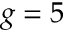Convert formula to latex. <formula><loc_0><loc_0><loc_500><loc_500>g = 5</formula> 